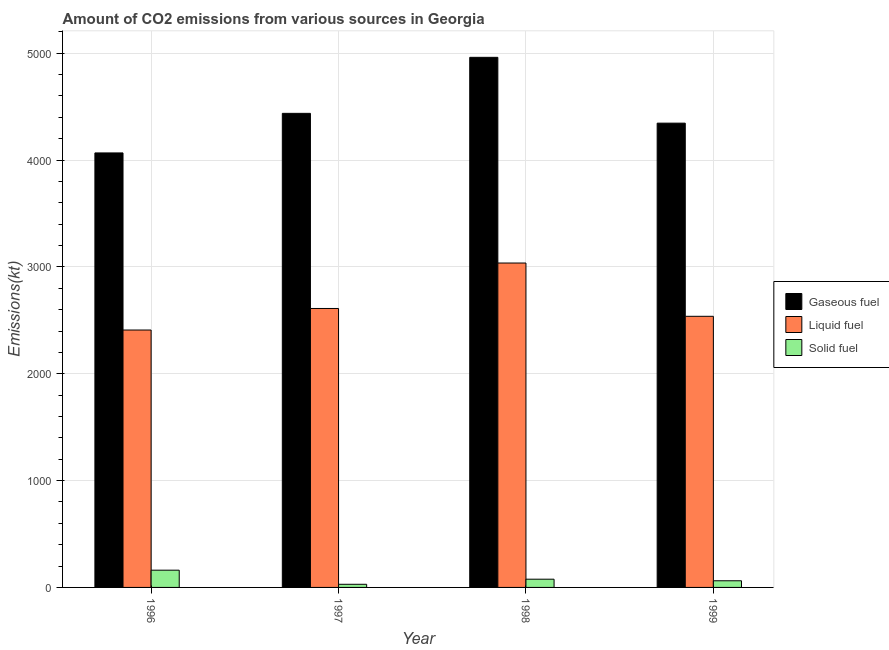Are the number of bars on each tick of the X-axis equal?
Offer a very short reply. Yes. How many bars are there on the 1st tick from the left?
Your answer should be very brief. 3. In how many cases, is the number of bars for a given year not equal to the number of legend labels?
Provide a succinct answer. 0. What is the amount of co2 emissions from liquid fuel in 1997?
Make the answer very short. 2610.9. Across all years, what is the maximum amount of co2 emissions from gaseous fuel?
Make the answer very short. 4961.45. Across all years, what is the minimum amount of co2 emissions from liquid fuel?
Your answer should be very brief. 2409.22. In which year was the amount of co2 emissions from gaseous fuel minimum?
Your answer should be compact. 1996. What is the total amount of co2 emissions from liquid fuel in the graph?
Your response must be concise. 1.06e+04. What is the difference between the amount of co2 emissions from liquid fuel in 1998 and that in 1999?
Your response must be concise. 498.71. What is the difference between the amount of co2 emissions from gaseous fuel in 1996 and the amount of co2 emissions from solid fuel in 1998?
Offer a terse response. -894.75. What is the average amount of co2 emissions from gaseous fuel per year?
Provide a short and direct response. 4452.65. In the year 1999, what is the difference between the amount of co2 emissions from liquid fuel and amount of co2 emissions from gaseous fuel?
Provide a succinct answer. 0. In how many years, is the amount of co2 emissions from gaseous fuel greater than 2200 kt?
Offer a terse response. 4. What is the ratio of the amount of co2 emissions from liquid fuel in 1997 to that in 1998?
Give a very brief answer. 0.86. Is the amount of co2 emissions from liquid fuel in 1997 less than that in 1998?
Give a very brief answer. Yes. What is the difference between the highest and the second highest amount of co2 emissions from solid fuel?
Give a very brief answer. 84.34. What is the difference between the highest and the lowest amount of co2 emissions from gaseous fuel?
Your answer should be compact. 894.75. What does the 1st bar from the left in 1997 represents?
Your response must be concise. Gaseous fuel. What does the 2nd bar from the right in 1997 represents?
Your response must be concise. Liquid fuel. How many bars are there?
Offer a terse response. 12. Are all the bars in the graph horizontal?
Make the answer very short. No. How many years are there in the graph?
Offer a terse response. 4. Are the values on the major ticks of Y-axis written in scientific E-notation?
Ensure brevity in your answer.  No. Where does the legend appear in the graph?
Your answer should be very brief. Center right. How many legend labels are there?
Provide a succinct answer. 3. How are the legend labels stacked?
Give a very brief answer. Vertical. What is the title of the graph?
Offer a terse response. Amount of CO2 emissions from various sources in Georgia. What is the label or title of the Y-axis?
Your response must be concise. Emissions(kt). What is the Emissions(kt) of Gaseous fuel in 1996?
Make the answer very short. 4066.7. What is the Emissions(kt) of Liquid fuel in 1996?
Offer a very short reply. 2409.22. What is the Emissions(kt) in Solid fuel in 1996?
Provide a short and direct response. 161.35. What is the Emissions(kt) of Gaseous fuel in 1997?
Ensure brevity in your answer.  4437.07. What is the Emissions(kt) of Liquid fuel in 1997?
Provide a short and direct response. 2610.9. What is the Emissions(kt) of Solid fuel in 1997?
Offer a terse response. 29.34. What is the Emissions(kt) of Gaseous fuel in 1998?
Offer a very short reply. 4961.45. What is the Emissions(kt) of Liquid fuel in 1998?
Offer a terse response. 3036.28. What is the Emissions(kt) of Solid fuel in 1998?
Make the answer very short. 77.01. What is the Emissions(kt) of Gaseous fuel in 1999?
Ensure brevity in your answer.  4345.4. What is the Emissions(kt) in Liquid fuel in 1999?
Provide a short and direct response. 2537.56. What is the Emissions(kt) of Solid fuel in 1999?
Keep it short and to the point. 62.34. Across all years, what is the maximum Emissions(kt) in Gaseous fuel?
Offer a very short reply. 4961.45. Across all years, what is the maximum Emissions(kt) of Liquid fuel?
Give a very brief answer. 3036.28. Across all years, what is the maximum Emissions(kt) of Solid fuel?
Provide a short and direct response. 161.35. Across all years, what is the minimum Emissions(kt) of Gaseous fuel?
Give a very brief answer. 4066.7. Across all years, what is the minimum Emissions(kt) in Liquid fuel?
Ensure brevity in your answer.  2409.22. Across all years, what is the minimum Emissions(kt) of Solid fuel?
Your answer should be very brief. 29.34. What is the total Emissions(kt) in Gaseous fuel in the graph?
Give a very brief answer. 1.78e+04. What is the total Emissions(kt) of Liquid fuel in the graph?
Provide a succinct answer. 1.06e+04. What is the total Emissions(kt) in Solid fuel in the graph?
Your answer should be very brief. 330.03. What is the difference between the Emissions(kt) of Gaseous fuel in 1996 and that in 1997?
Keep it short and to the point. -370.37. What is the difference between the Emissions(kt) of Liquid fuel in 1996 and that in 1997?
Keep it short and to the point. -201.69. What is the difference between the Emissions(kt) in Solid fuel in 1996 and that in 1997?
Your answer should be compact. 132.01. What is the difference between the Emissions(kt) of Gaseous fuel in 1996 and that in 1998?
Keep it short and to the point. -894.75. What is the difference between the Emissions(kt) of Liquid fuel in 1996 and that in 1998?
Give a very brief answer. -627.06. What is the difference between the Emissions(kt) of Solid fuel in 1996 and that in 1998?
Provide a short and direct response. 84.34. What is the difference between the Emissions(kt) of Gaseous fuel in 1996 and that in 1999?
Your response must be concise. -278.69. What is the difference between the Emissions(kt) in Liquid fuel in 1996 and that in 1999?
Offer a terse response. -128.34. What is the difference between the Emissions(kt) of Solid fuel in 1996 and that in 1999?
Keep it short and to the point. 99.01. What is the difference between the Emissions(kt) in Gaseous fuel in 1997 and that in 1998?
Make the answer very short. -524.38. What is the difference between the Emissions(kt) in Liquid fuel in 1997 and that in 1998?
Make the answer very short. -425.37. What is the difference between the Emissions(kt) in Solid fuel in 1997 and that in 1998?
Make the answer very short. -47.67. What is the difference between the Emissions(kt) of Gaseous fuel in 1997 and that in 1999?
Offer a terse response. 91.67. What is the difference between the Emissions(kt) in Liquid fuel in 1997 and that in 1999?
Provide a succinct answer. 73.34. What is the difference between the Emissions(kt) of Solid fuel in 1997 and that in 1999?
Provide a short and direct response. -33. What is the difference between the Emissions(kt) of Gaseous fuel in 1998 and that in 1999?
Make the answer very short. 616.06. What is the difference between the Emissions(kt) in Liquid fuel in 1998 and that in 1999?
Provide a succinct answer. 498.71. What is the difference between the Emissions(kt) of Solid fuel in 1998 and that in 1999?
Your answer should be very brief. 14.67. What is the difference between the Emissions(kt) in Gaseous fuel in 1996 and the Emissions(kt) in Liquid fuel in 1997?
Provide a succinct answer. 1455.8. What is the difference between the Emissions(kt) in Gaseous fuel in 1996 and the Emissions(kt) in Solid fuel in 1997?
Offer a very short reply. 4037.37. What is the difference between the Emissions(kt) of Liquid fuel in 1996 and the Emissions(kt) of Solid fuel in 1997?
Your answer should be very brief. 2379.88. What is the difference between the Emissions(kt) of Gaseous fuel in 1996 and the Emissions(kt) of Liquid fuel in 1998?
Your response must be concise. 1030.43. What is the difference between the Emissions(kt) of Gaseous fuel in 1996 and the Emissions(kt) of Solid fuel in 1998?
Provide a succinct answer. 3989.7. What is the difference between the Emissions(kt) of Liquid fuel in 1996 and the Emissions(kt) of Solid fuel in 1998?
Offer a very short reply. 2332.21. What is the difference between the Emissions(kt) of Gaseous fuel in 1996 and the Emissions(kt) of Liquid fuel in 1999?
Ensure brevity in your answer.  1529.14. What is the difference between the Emissions(kt) of Gaseous fuel in 1996 and the Emissions(kt) of Solid fuel in 1999?
Provide a succinct answer. 4004.36. What is the difference between the Emissions(kt) of Liquid fuel in 1996 and the Emissions(kt) of Solid fuel in 1999?
Your answer should be compact. 2346.88. What is the difference between the Emissions(kt) of Gaseous fuel in 1997 and the Emissions(kt) of Liquid fuel in 1998?
Keep it short and to the point. 1400.79. What is the difference between the Emissions(kt) of Gaseous fuel in 1997 and the Emissions(kt) of Solid fuel in 1998?
Provide a short and direct response. 4360.06. What is the difference between the Emissions(kt) in Liquid fuel in 1997 and the Emissions(kt) in Solid fuel in 1998?
Provide a succinct answer. 2533.9. What is the difference between the Emissions(kt) in Gaseous fuel in 1997 and the Emissions(kt) in Liquid fuel in 1999?
Ensure brevity in your answer.  1899.51. What is the difference between the Emissions(kt) of Gaseous fuel in 1997 and the Emissions(kt) of Solid fuel in 1999?
Make the answer very short. 4374.73. What is the difference between the Emissions(kt) in Liquid fuel in 1997 and the Emissions(kt) in Solid fuel in 1999?
Your response must be concise. 2548.57. What is the difference between the Emissions(kt) of Gaseous fuel in 1998 and the Emissions(kt) of Liquid fuel in 1999?
Offer a very short reply. 2423.89. What is the difference between the Emissions(kt) in Gaseous fuel in 1998 and the Emissions(kt) in Solid fuel in 1999?
Offer a very short reply. 4899.11. What is the difference between the Emissions(kt) in Liquid fuel in 1998 and the Emissions(kt) in Solid fuel in 1999?
Keep it short and to the point. 2973.94. What is the average Emissions(kt) of Gaseous fuel per year?
Keep it short and to the point. 4452.65. What is the average Emissions(kt) of Liquid fuel per year?
Your answer should be compact. 2648.49. What is the average Emissions(kt) of Solid fuel per year?
Your answer should be very brief. 82.51. In the year 1996, what is the difference between the Emissions(kt) in Gaseous fuel and Emissions(kt) in Liquid fuel?
Provide a short and direct response. 1657.48. In the year 1996, what is the difference between the Emissions(kt) in Gaseous fuel and Emissions(kt) in Solid fuel?
Provide a short and direct response. 3905.36. In the year 1996, what is the difference between the Emissions(kt) of Liquid fuel and Emissions(kt) of Solid fuel?
Make the answer very short. 2247.87. In the year 1997, what is the difference between the Emissions(kt) in Gaseous fuel and Emissions(kt) in Liquid fuel?
Offer a terse response. 1826.17. In the year 1997, what is the difference between the Emissions(kt) of Gaseous fuel and Emissions(kt) of Solid fuel?
Give a very brief answer. 4407.73. In the year 1997, what is the difference between the Emissions(kt) of Liquid fuel and Emissions(kt) of Solid fuel?
Give a very brief answer. 2581.57. In the year 1998, what is the difference between the Emissions(kt) in Gaseous fuel and Emissions(kt) in Liquid fuel?
Your response must be concise. 1925.17. In the year 1998, what is the difference between the Emissions(kt) in Gaseous fuel and Emissions(kt) in Solid fuel?
Offer a very short reply. 4884.44. In the year 1998, what is the difference between the Emissions(kt) of Liquid fuel and Emissions(kt) of Solid fuel?
Keep it short and to the point. 2959.27. In the year 1999, what is the difference between the Emissions(kt) in Gaseous fuel and Emissions(kt) in Liquid fuel?
Provide a succinct answer. 1807.83. In the year 1999, what is the difference between the Emissions(kt) in Gaseous fuel and Emissions(kt) in Solid fuel?
Provide a succinct answer. 4283.06. In the year 1999, what is the difference between the Emissions(kt) in Liquid fuel and Emissions(kt) in Solid fuel?
Provide a succinct answer. 2475.22. What is the ratio of the Emissions(kt) of Gaseous fuel in 1996 to that in 1997?
Your answer should be compact. 0.92. What is the ratio of the Emissions(kt) in Liquid fuel in 1996 to that in 1997?
Keep it short and to the point. 0.92. What is the ratio of the Emissions(kt) of Solid fuel in 1996 to that in 1997?
Give a very brief answer. 5.5. What is the ratio of the Emissions(kt) in Gaseous fuel in 1996 to that in 1998?
Your response must be concise. 0.82. What is the ratio of the Emissions(kt) of Liquid fuel in 1996 to that in 1998?
Keep it short and to the point. 0.79. What is the ratio of the Emissions(kt) of Solid fuel in 1996 to that in 1998?
Provide a short and direct response. 2.1. What is the ratio of the Emissions(kt) in Gaseous fuel in 1996 to that in 1999?
Provide a succinct answer. 0.94. What is the ratio of the Emissions(kt) in Liquid fuel in 1996 to that in 1999?
Offer a terse response. 0.95. What is the ratio of the Emissions(kt) in Solid fuel in 1996 to that in 1999?
Ensure brevity in your answer.  2.59. What is the ratio of the Emissions(kt) in Gaseous fuel in 1997 to that in 1998?
Offer a terse response. 0.89. What is the ratio of the Emissions(kt) in Liquid fuel in 1997 to that in 1998?
Keep it short and to the point. 0.86. What is the ratio of the Emissions(kt) of Solid fuel in 1997 to that in 1998?
Your response must be concise. 0.38. What is the ratio of the Emissions(kt) of Gaseous fuel in 1997 to that in 1999?
Offer a very short reply. 1.02. What is the ratio of the Emissions(kt) of Liquid fuel in 1997 to that in 1999?
Your response must be concise. 1.03. What is the ratio of the Emissions(kt) of Solid fuel in 1997 to that in 1999?
Keep it short and to the point. 0.47. What is the ratio of the Emissions(kt) of Gaseous fuel in 1998 to that in 1999?
Make the answer very short. 1.14. What is the ratio of the Emissions(kt) in Liquid fuel in 1998 to that in 1999?
Your answer should be compact. 1.2. What is the ratio of the Emissions(kt) of Solid fuel in 1998 to that in 1999?
Your answer should be very brief. 1.24. What is the difference between the highest and the second highest Emissions(kt) of Gaseous fuel?
Your response must be concise. 524.38. What is the difference between the highest and the second highest Emissions(kt) in Liquid fuel?
Your response must be concise. 425.37. What is the difference between the highest and the second highest Emissions(kt) in Solid fuel?
Keep it short and to the point. 84.34. What is the difference between the highest and the lowest Emissions(kt) of Gaseous fuel?
Offer a terse response. 894.75. What is the difference between the highest and the lowest Emissions(kt) in Liquid fuel?
Your response must be concise. 627.06. What is the difference between the highest and the lowest Emissions(kt) in Solid fuel?
Offer a very short reply. 132.01. 